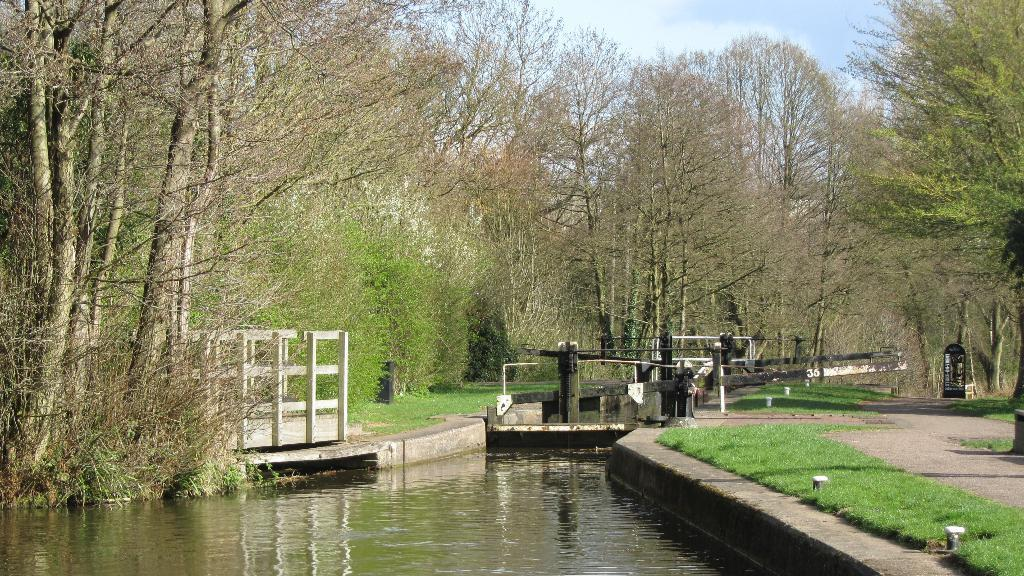What is the main feature in the center of the image? There is water in the center of the image. What type of vegetation can be seen in the image? There are trees and grass in the image. What structures are present in the image? There are poles and a fence in the image. What recreational object is visible in the image? There is a swing in the image. What else can be seen in the image besides the mentioned objects? There are other objects in the image. What is visible in the background of the image? The sky, clouds, and trees are visible in the background of the image. How many balloons are tied to the branch in the image? There are no balloons or branches present in the image. What type of fold can be seen in the image? There is no fold visible in the image. 